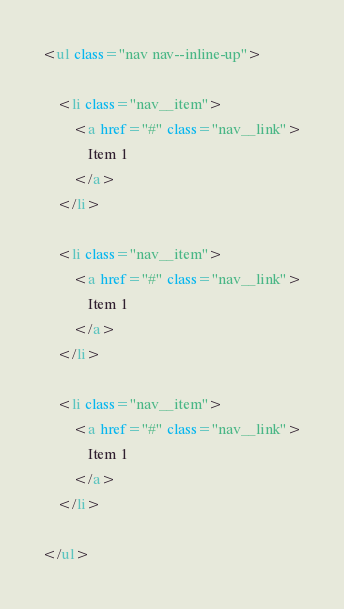<code> <loc_0><loc_0><loc_500><loc_500><_HTML_><ul class="nav nav--inline-up">

    <li class="nav__item">
        <a href="#" class="nav__link">
            Item 1
        </a>
    </li>

    <li class="nav__item">
        <a href="#" class="nav__link">
            Item 1
        </a>
    </li>

    <li class="nav__item">
        <a href="#" class="nav__link">
            Item 1
        </a>
    </li>

</ul>
</code> 